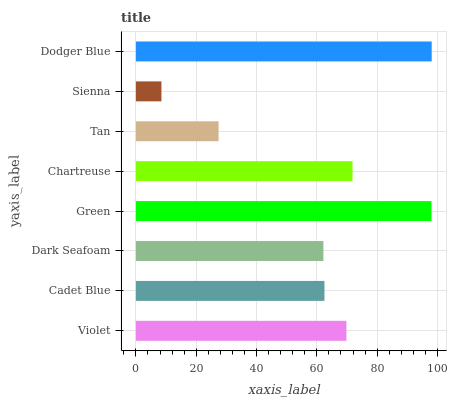Is Sienna the minimum?
Answer yes or no. Yes. Is Dodger Blue the maximum?
Answer yes or no. Yes. Is Cadet Blue the minimum?
Answer yes or no. No. Is Cadet Blue the maximum?
Answer yes or no. No. Is Violet greater than Cadet Blue?
Answer yes or no. Yes. Is Cadet Blue less than Violet?
Answer yes or no. Yes. Is Cadet Blue greater than Violet?
Answer yes or no. No. Is Violet less than Cadet Blue?
Answer yes or no. No. Is Violet the high median?
Answer yes or no. Yes. Is Cadet Blue the low median?
Answer yes or no. Yes. Is Sienna the high median?
Answer yes or no. No. Is Violet the low median?
Answer yes or no. No. 